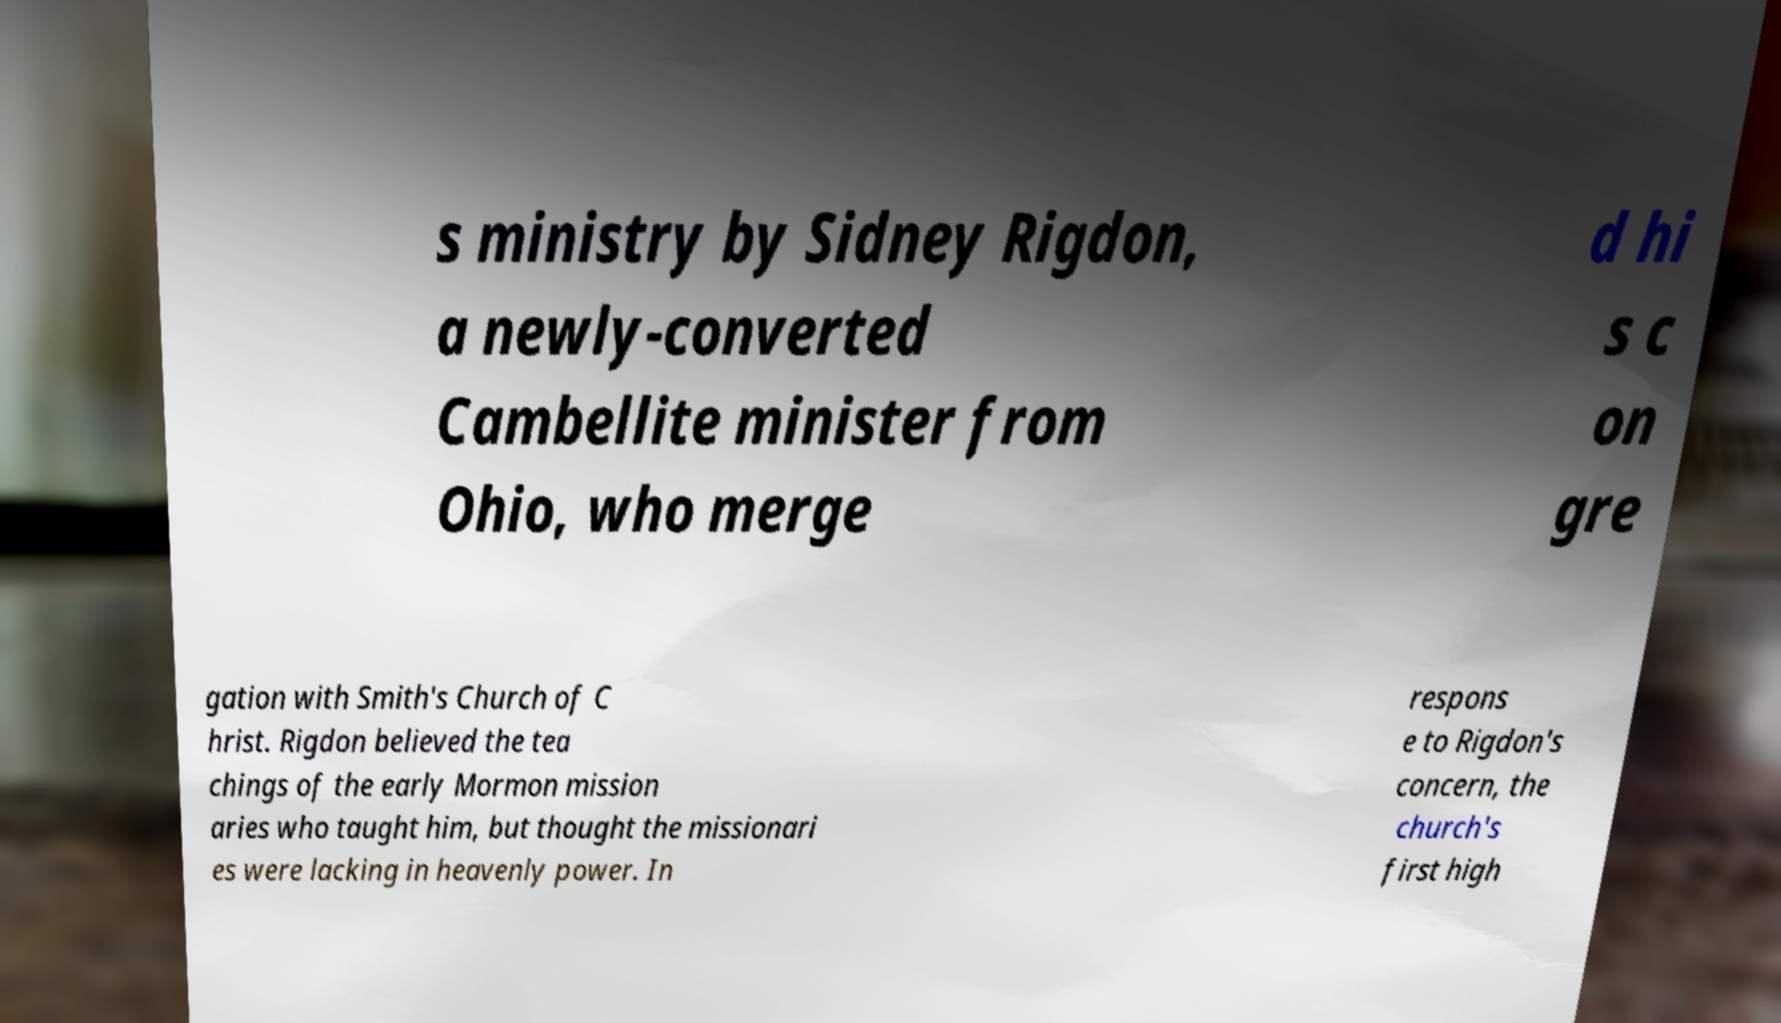Could you extract and type out the text from this image? s ministry by Sidney Rigdon, a newly-converted Cambellite minister from Ohio, who merge d hi s c on gre gation with Smith's Church of C hrist. Rigdon believed the tea chings of the early Mormon mission aries who taught him, but thought the missionari es were lacking in heavenly power. In respons e to Rigdon's concern, the church's first high 